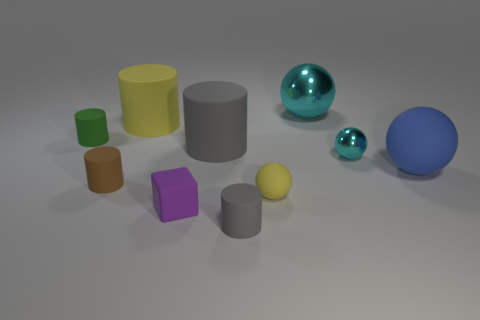What material is the cyan thing that is the same size as the green thing? The cyan object, which appears to be a reflective sphere and is comparable in size to the green cylinder, looks like it is made of a polished metal, possibly stainless steel or chrome, due to its shiny surface and clear reflections. 